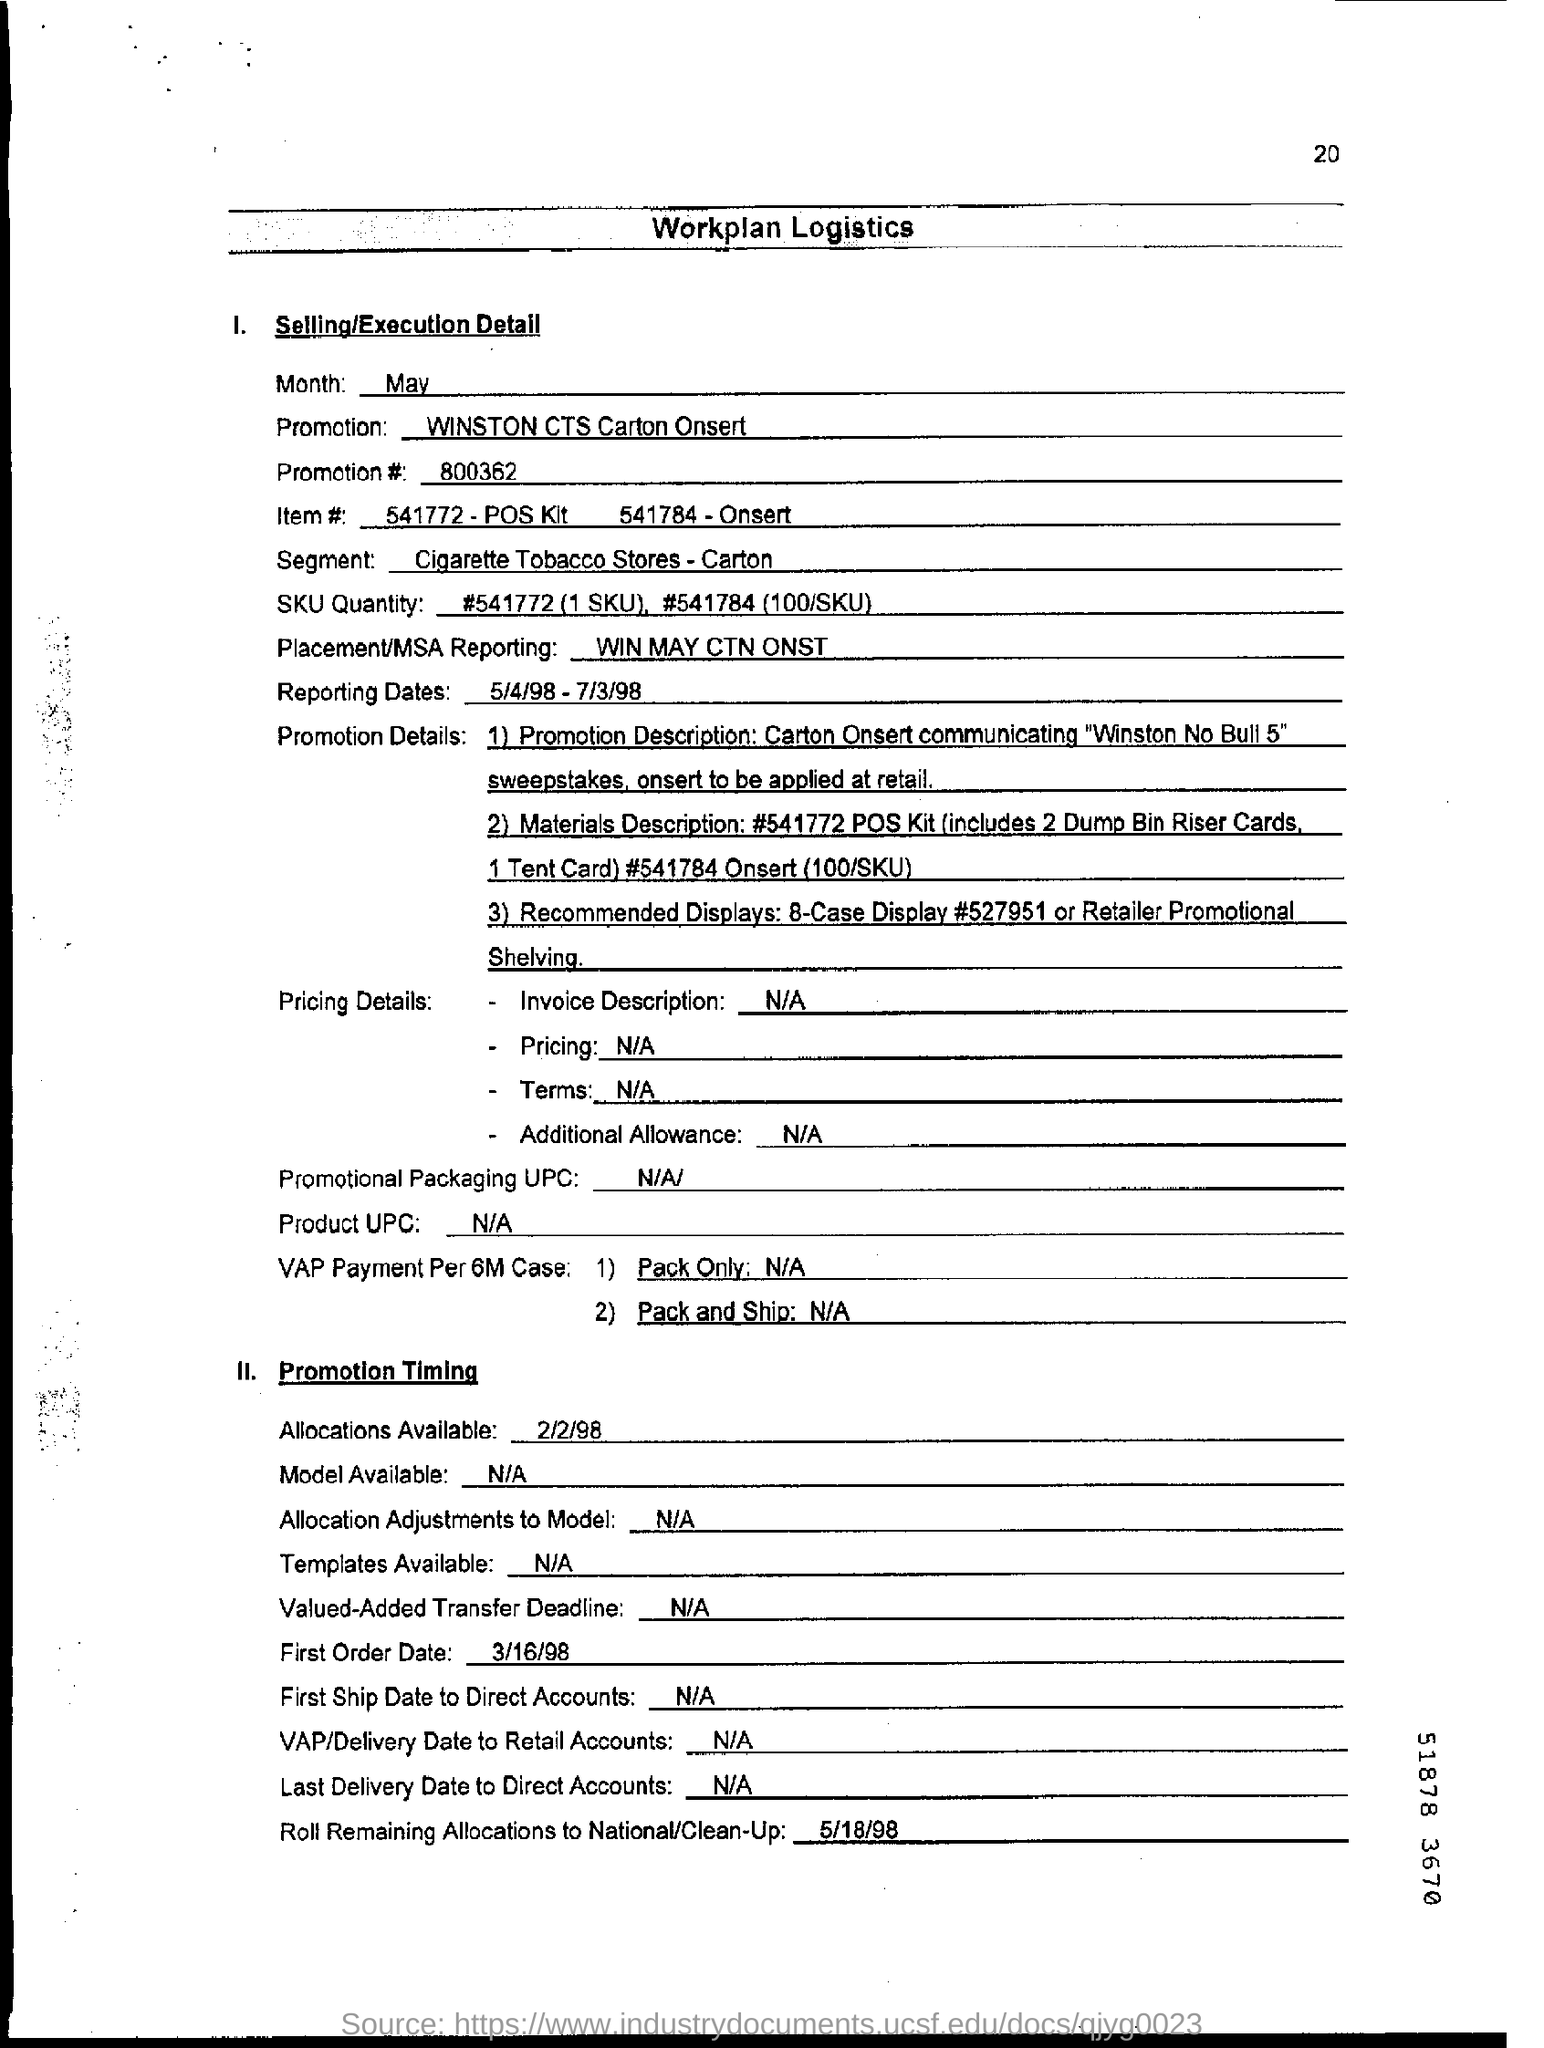Outline some significant characteristics in this image. The placement or MSA reporting as indicated in the document is to win may ctn onst. The promotion number mentioned in the document is 800362. The reported dates according to the document are from May 4, 1998 to July 3, 1998. 